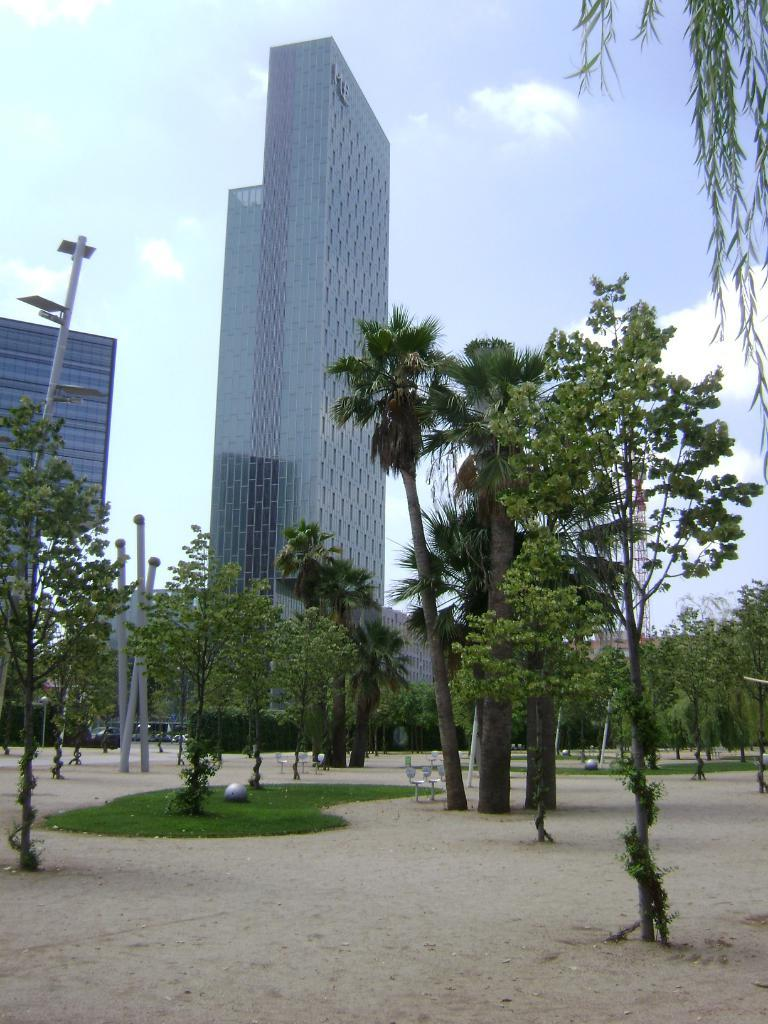What type of structures can be seen in the image? There are buildings in the image. What are the vertical objects in the image? There are poles in the image. What type of vegetation is present in the image? There are trees, plants, and grass in the image. What is at the bottom of the image? There is a ground at the bottom of the image. What else can be seen in the image besides the structures and vegetation? There are objects in the image. What is visible in the background of the image? The sky is visible in the background of the image. What type of note can be seen hanging from the trees in the image? There is no note present in the image; it only features buildings, poles, trees, plants, grass, ground, objects, and the sky. What is the visibility like in the image due to the presence of fog? There is no mention of fog in the image, and the visibility appears to be clear as the sky is visible in the background. 